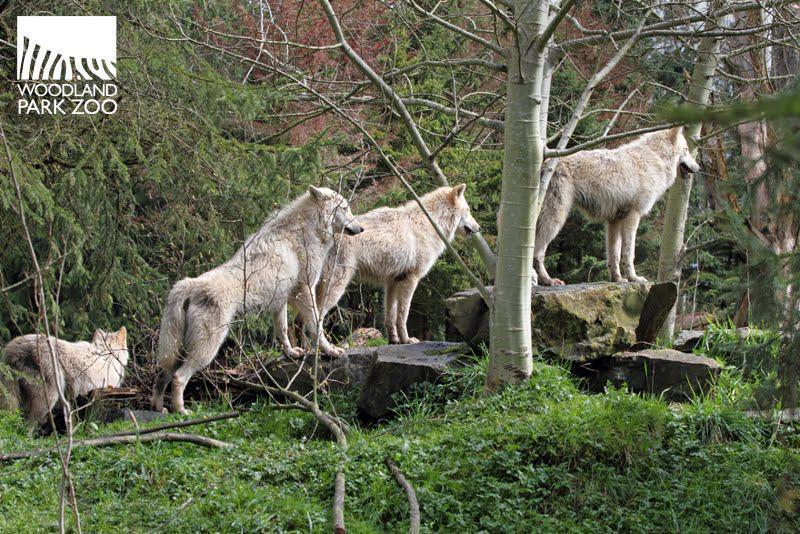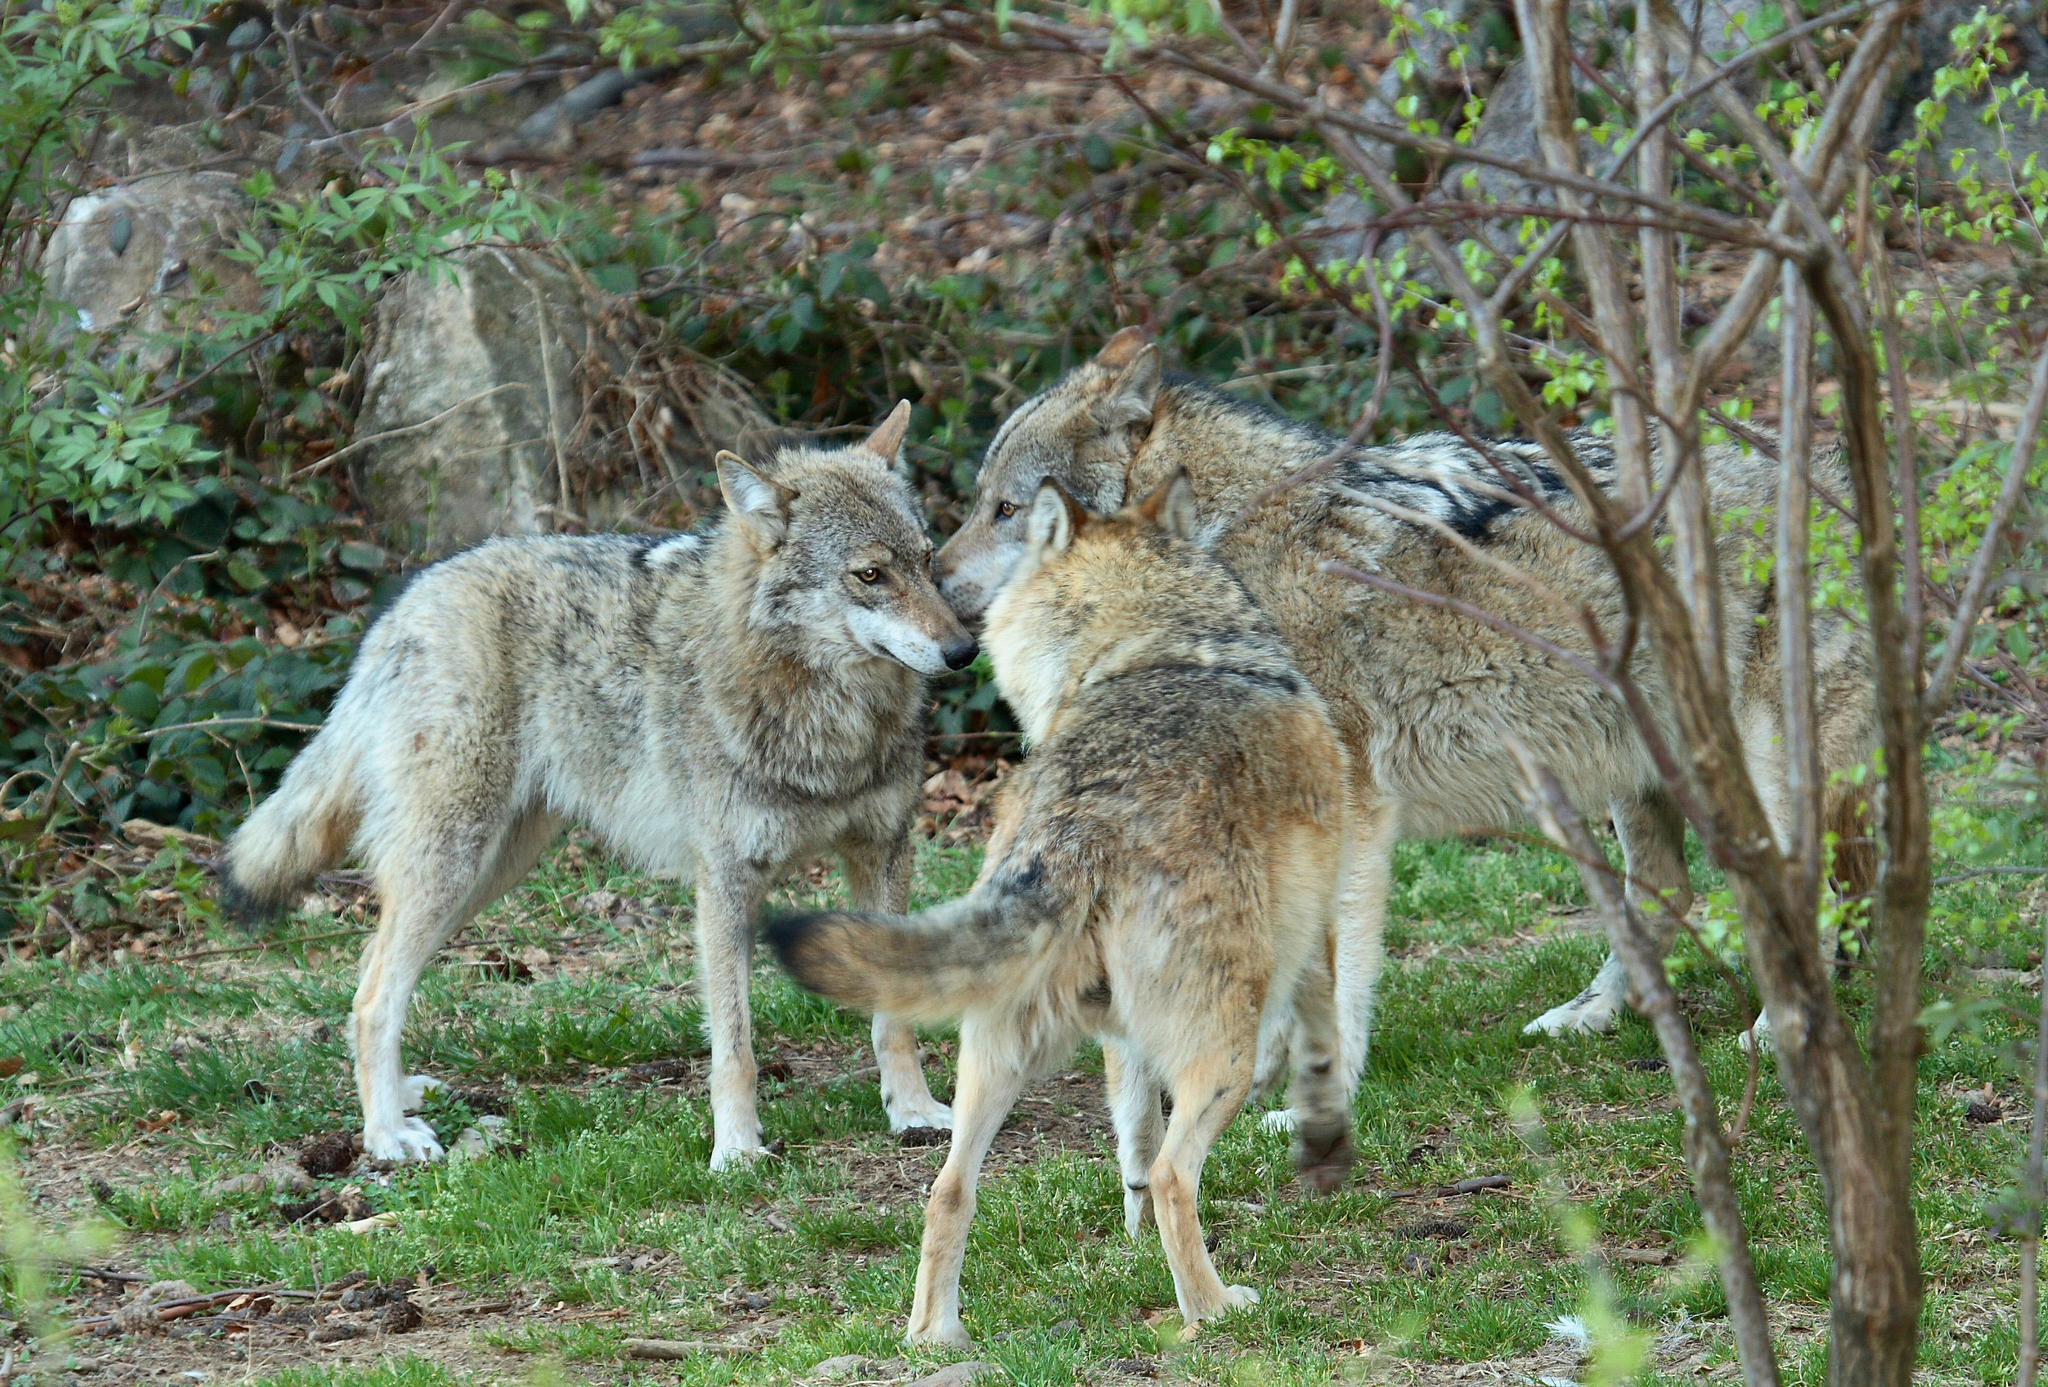The first image is the image on the left, the second image is the image on the right. Given the left and right images, does the statement "One image contains four wolves, several of which are perched on large grey rocks, and several facing rightward with heads high." hold true? Answer yes or no. Yes. The first image is the image on the left, the second image is the image on the right. Examine the images to the left and right. Is the description "In the right image there are three adult wolves." accurate? Answer yes or no. Yes. 